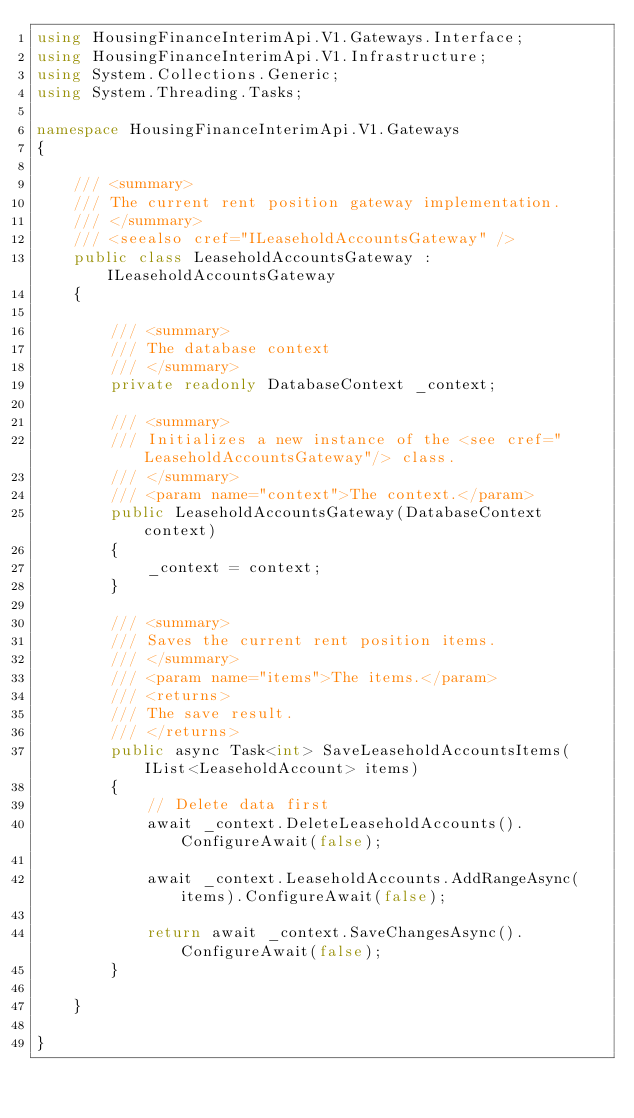Convert code to text. <code><loc_0><loc_0><loc_500><loc_500><_C#_>using HousingFinanceInterimApi.V1.Gateways.Interface;
using HousingFinanceInterimApi.V1.Infrastructure;
using System.Collections.Generic;
using System.Threading.Tasks;

namespace HousingFinanceInterimApi.V1.Gateways
{

    /// <summary>
    /// The current rent position gateway implementation.
    /// </summary>
    /// <seealso cref="ILeaseholdAccountsGateway" />
    public class LeaseholdAccountsGateway : ILeaseholdAccountsGateway
    {

        /// <summary>
        /// The database context
        /// </summary>
        private readonly DatabaseContext _context;

        /// <summary>
        /// Initializes a new instance of the <see cref="LeaseholdAccountsGateway"/> class.
        /// </summary>
        /// <param name="context">The context.</param>
        public LeaseholdAccountsGateway(DatabaseContext context)
        {
            _context = context;
        }

        /// <summary>
        /// Saves the current rent position items.
        /// </summary>
        /// <param name="items">The items.</param>
        /// <returns>
        /// The save result.
        /// </returns>
        public async Task<int> SaveLeaseholdAccountsItems(IList<LeaseholdAccount> items)
        {
            // Delete data first
            await _context.DeleteLeaseholdAccounts().ConfigureAwait(false);

            await _context.LeaseholdAccounts.AddRangeAsync(items).ConfigureAwait(false);

            return await _context.SaveChangesAsync().ConfigureAwait(false);
        }

    }

}
</code> 